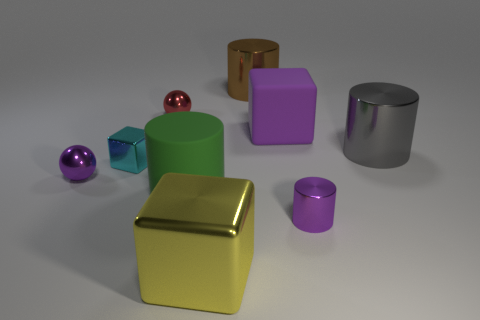Subtract all tiny shiny cylinders. How many cylinders are left? 3 Subtract all spheres. How many objects are left? 7 Subtract 3 cylinders. How many cylinders are left? 1 Subtract all purple cylinders. Subtract all cyan balls. How many cylinders are left? 3 Subtract all gray cylinders. How many yellow balls are left? 0 Subtract all tiny cyan metal cylinders. Subtract all cyan blocks. How many objects are left? 8 Add 3 purple shiny things. How many purple shiny things are left? 5 Add 2 large green matte cylinders. How many large green matte cylinders exist? 3 Add 1 small red rubber things. How many objects exist? 10 Subtract all brown cylinders. How many cylinders are left? 3 